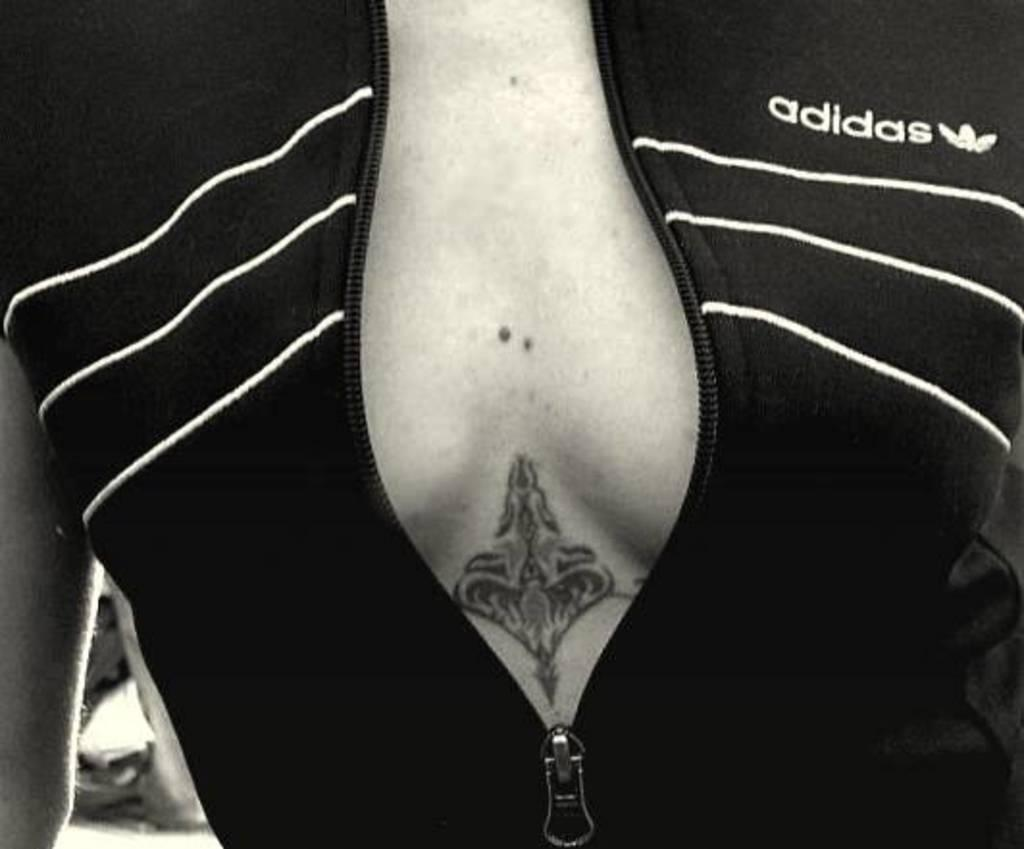What is the color scheme of the image? The image is black and white. Can you describe the person in the image? There is a person in the image. What type of clothing is the person wearing? The person is wearing a jacket. Are there any visible markings or designs on the person's body? The person has a tattoo on their body. What type of fowl can be seen in the image? There is no fowl present in the image; it features a person wearing a jacket and has a tattoo. How many potatoes are visible in the image? There are no potatoes present in the image. 